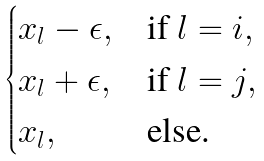Convert formula to latex. <formula><loc_0><loc_0><loc_500><loc_500>\begin{cases} x _ { l } - \epsilon , & \text {if } l = i , \\ x _ { l } + \epsilon , & \text {if } l = j , \\ x _ { l } , & \text {else.} \end{cases}</formula> 